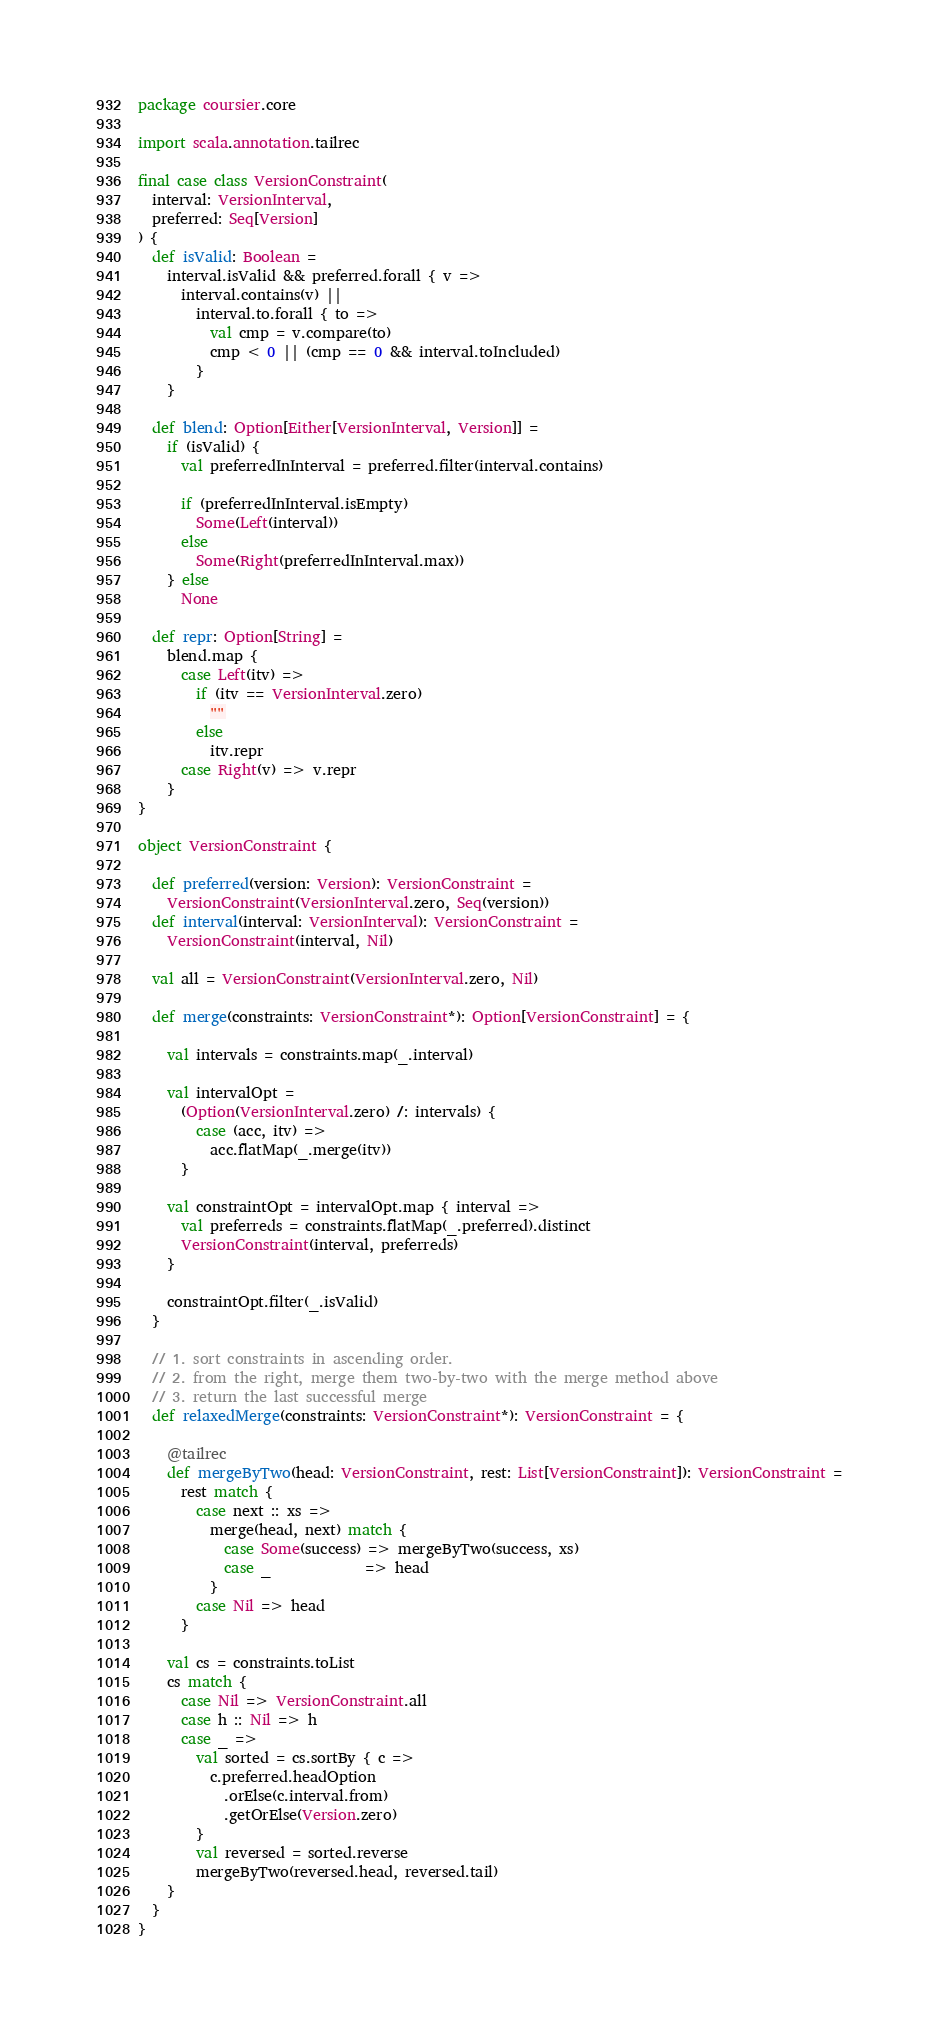<code> <loc_0><loc_0><loc_500><loc_500><_Scala_>package coursier.core

import scala.annotation.tailrec

final case class VersionConstraint(
  interval: VersionInterval,
  preferred: Seq[Version]
) {
  def isValid: Boolean =
    interval.isValid && preferred.forall { v =>
      interval.contains(v) ||
        interval.to.forall { to =>
          val cmp = v.compare(to)
          cmp < 0 || (cmp == 0 && interval.toIncluded)
        }
    }

  def blend: Option[Either[VersionInterval, Version]] =
    if (isValid) {
      val preferredInInterval = preferred.filter(interval.contains)

      if (preferredInInterval.isEmpty)
        Some(Left(interval))
      else
        Some(Right(preferredInInterval.max))
    } else
      None

  def repr: Option[String] =
    blend.map {
      case Left(itv) =>
        if (itv == VersionInterval.zero)
          ""
        else
          itv.repr
      case Right(v) => v.repr
    }
}

object VersionConstraint {

  def preferred(version: Version): VersionConstraint =
    VersionConstraint(VersionInterval.zero, Seq(version))
  def interval(interval: VersionInterval): VersionConstraint =
    VersionConstraint(interval, Nil)

  val all = VersionConstraint(VersionInterval.zero, Nil)

  def merge(constraints: VersionConstraint*): Option[VersionConstraint] = {

    val intervals = constraints.map(_.interval)

    val intervalOpt =
      (Option(VersionInterval.zero) /: intervals) {
        case (acc, itv) =>
          acc.flatMap(_.merge(itv))
      }

    val constraintOpt = intervalOpt.map { interval =>
      val preferreds = constraints.flatMap(_.preferred).distinct
      VersionConstraint(interval, preferreds)
    }

    constraintOpt.filter(_.isValid)
  }

  // 1. sort constraints in ascending order.
  // 2. from the right, merge them two-by-two with the merge method above
  // 3. return the last successful merge
  def relaxedMerge(constraints: VersionConstraint*): VersionConstraint = {

    @tailrec
    def mergeByTwo(head: VersionConstraint, rest: List[VersionConstraint]): VersionConstraint =
      rest match {
        case next :: xs =>
          merge(head, next) match {
            case Some(success) => mergeByTwo(success, xs)
            case _             => head
          }
        case Nil => head
      }

    val cs = constraints.toList
    cs match {
      case Nil => VersionConstraint.all
      case h :: Nil => h
      case _ =>
        val sorted = cs.sortBy { c =>
          c.preferred.headOption
            .orElse(c.interval.from)
            .getOrElse(Version.zero)
        }
        val reversed = sorted.reverse
        mergeByTwo(reversed.head, reversed.tail)
    }
  }
}
</code> 